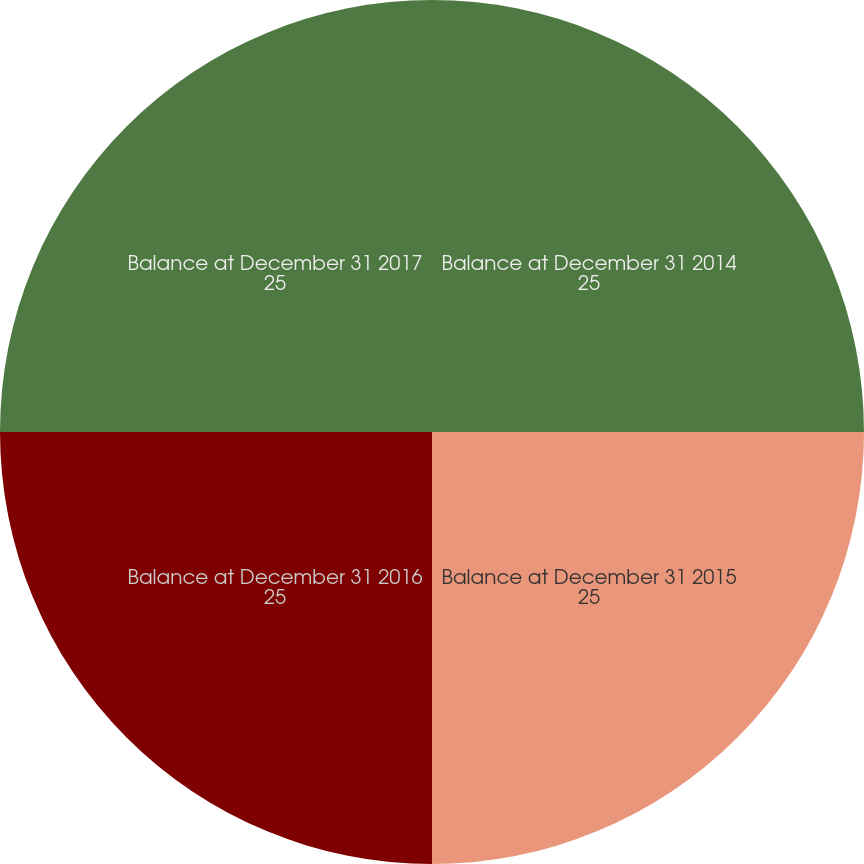<chart> <loc_0><loc_0><loc_500><loc_500><pie_chart><fcel>Balance at December 31 2014<fcel>Balance at December 31 2015<fcel>Balance at December 31 2016<fcel>Balance at December 31 2017<nl><fcel>25.0%<fcel>25.0%<fcel>25.0%<fcel>25.0%<nl></chart> 